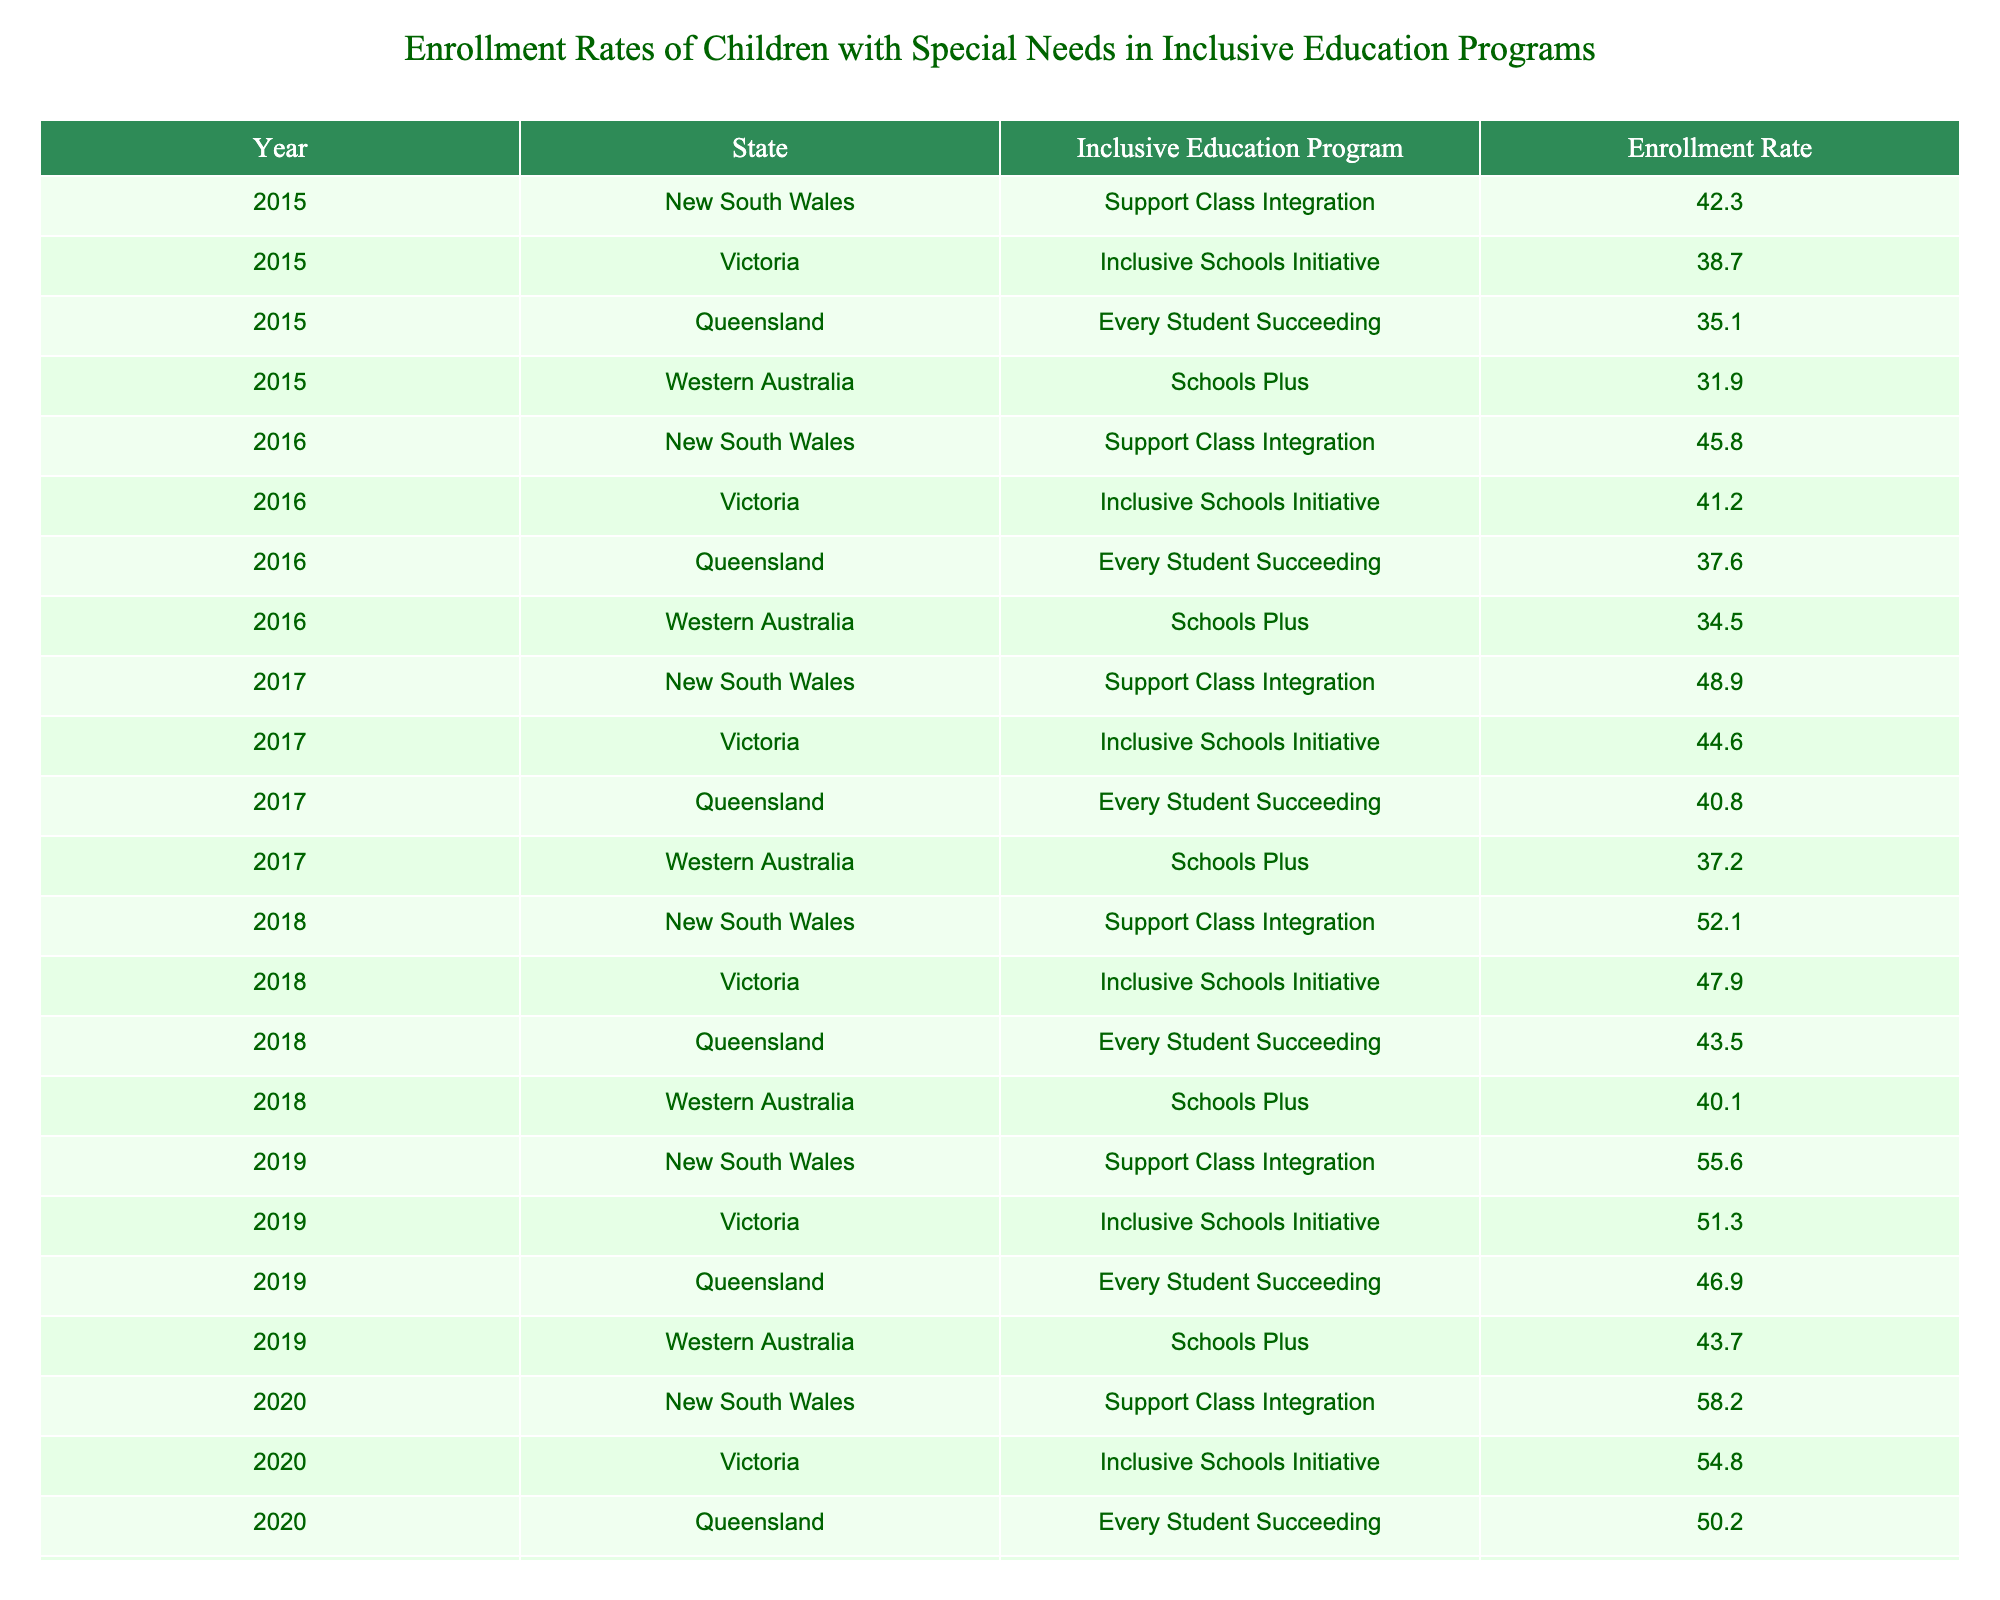What was the enrollment rate for Queensland in 2018? The table shows that in 2018, the enrollment rate for Queensland under the Every Student Succeeding program was 43.5.
Answer: 43.5 What was the increase in enrollment rate for New South Wales from 2015 to 2020? The enrollment rate for New South Wales in 2015 was 42.3 and in 2020 it was 58.2. The increase is calculated as 58.2 - 42.3 = 15.9.
Answer: 15.9 Which state had the highest enrollment rate in 2019? By comparing the enrollment rates for each state in 2019, New South Wales had 55.6, Victoria had 51.3, Queensland had 46.9, and Western Australia had 43.7. The highest is 55.6 from New South Wales.
Answer: New South Wales What was the average enrollment rate for Victoria over the years 2015 to 2020? The enrollment rates for Victoria from 2015 to 2020 are 38.7, 41.2, 44.6, 47.9, 51.3, and 54.8. Summing these gives 38.7 + 41.2 + 44.6 + 47.9 + 51.3 + 54.8 = 278.5. Dividing by 6 (the number of years) gives 278.5 / 6 ≈ 46.42.
Answer: 46.42 In which year did Western Australia have its lowest enrollment rate? Looking at the enrollment rate for Western Australia for each year, the rates were 31.9 in 2015, 34.5 in 2016, 37.2 in 2017, 40.1 in 2018, and 43.7 in 2019, and 47.3 in 2020. The lowest rate is 31.9 in 2015.
Answer: 2015 Is the enrollment rate for Queensland in 2017 greater than the enrollment rate for the same state in 2015? The enrollment rate for Queensland in 2017 is 40.8, and in 2015 it is 35.1. Since 40.8 is greater than 35.1, the statement is true.
Answer: Yes What was the total enrollment rate for all states in 2016? The enrollment rates for all states in 2016 are: New South Wales - 45.8, Victoria - 41.2, Queensland - 37.6, and Western Australia - 34.5. The total is 45.8 + 41.2 + 37.6 + 34.5 = 159.1.
Answer: 159.1 How much did the enrollment rate for Victoria increase from 2015 to 2018? The enrollment rate for Victoria in 2015 was 38.7 and in 2018 it was 47.9. The increase is 47.9 - 38.7 = 9.2.
Answer: 9.2 Which program had a consistent year-on-year increase in enrollment rates from 2015 to 2020? By reviewing the data for all programs for each year, Support Class Integration in New South Wales shows a consistent increase from 42.3 in 2015, reaching 58.2 in 2020.
Answer: Support Class Integration What was the enrollment rate for all states combined in 2019 versus 2020? The enrollment rates for 2019 were New South Wales - 55.6, Victoria - 51.3, Queensland - 46.9, and Western Australia - 43.7, totaling 197.5. For 2020, they were New South Wales - 58.2, Victoria - 54.8, Queensland - 50.2, and Western Australia - 47.3, totaling 210.5.
Answer: 210.5 is higher than 197.5 What percentage increase did the enrollment rate for New South Wales experience from 2015 to 2019? The enrollment rate in 2015 was 42.3 and in 2019 it was 55.6. The percentage increase is calculated as [(55.6 - 42.3) / 42.3] * 100 ≈ 31.4%.
Answer: 31.4% 